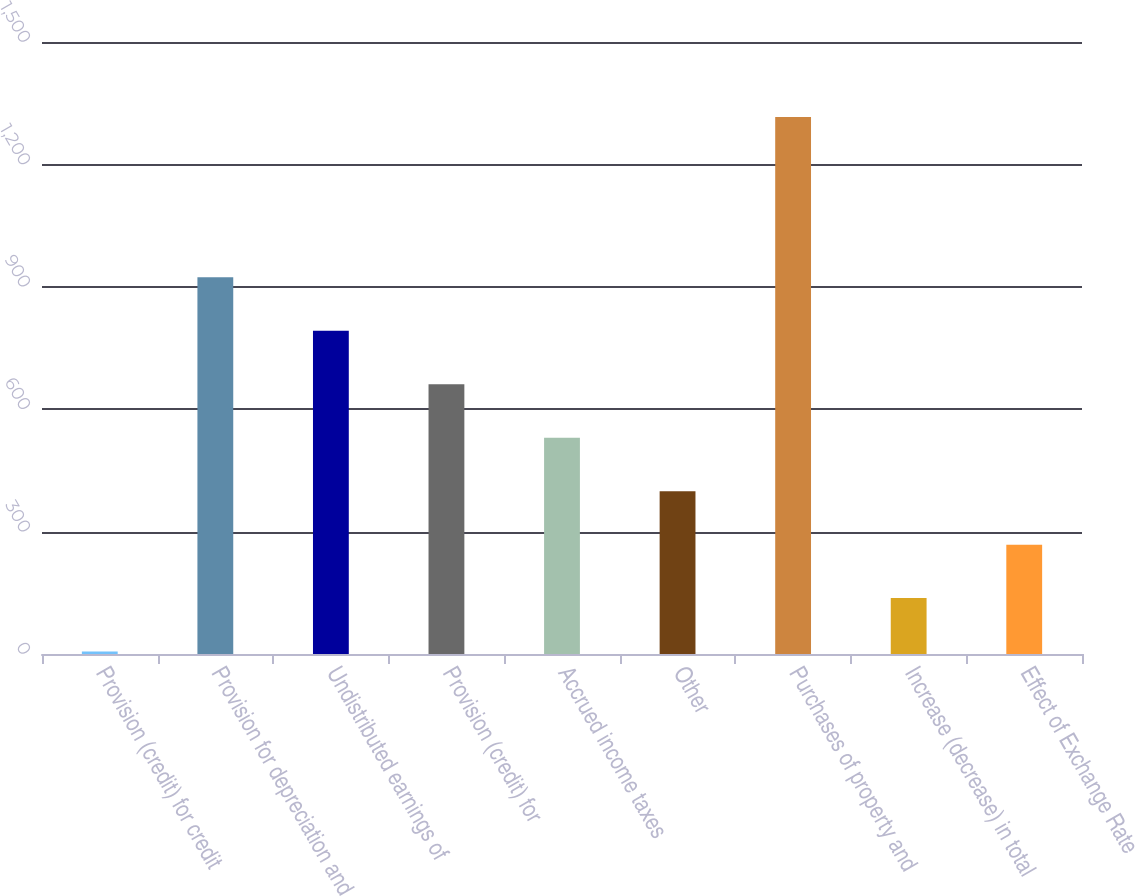Convert chart to OTSL. <chart><loc_0><loc_0><loc_500><loc_500><bar_chart><fcel>Provision (credit) for credit<fcel>Provision for depreciation and<fcel>Undistributed earnings of<fcel>Provision (credit) for<fcel>Accrued income taxes<fcel>Other<fcel>Purchases of property and<fcel>Increase (decrease) in total<fcel>Effect of Exchange Rate<nl><fcel>6<fcel>923.14<fcel>792.12<fcel>661.1<fcel>530.08<fcel>399.06<fcel>1316.2<fcel>137.02<fcel>268.04<nl></chart> 